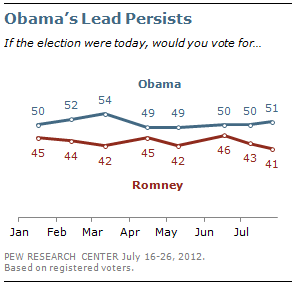Identify some key points in this picture. The data for Obama and Romney's opinion has two modes. The Romney data is smaller than Obama's data. The least value of the two lines is 41. 